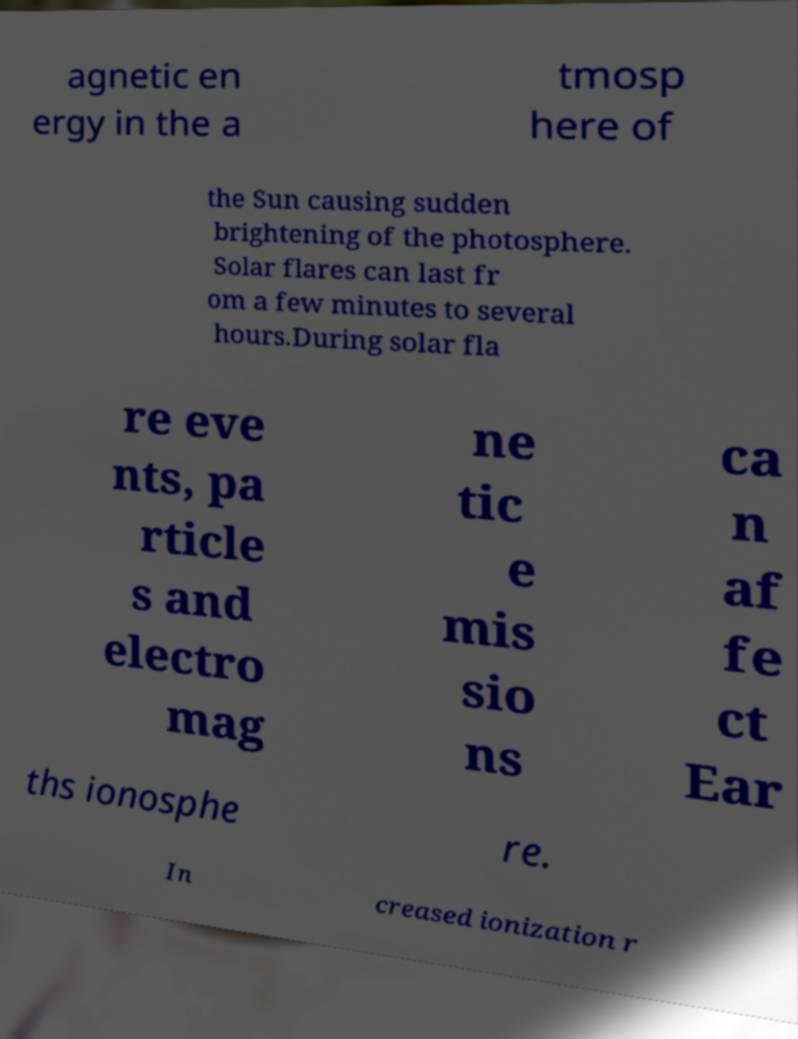Could you assist in decoding the text presented in this image and type it out clearly? agnetic en ergy in the a tmosp here of the Sun causing sudden brightening of the photosphere. Solar flares can last fr om a few minutes to several hours.During solar fla re eve nts, pa rticle s and electro mag ne tic e mis sio ns ca n af fe ct Ear ths ionosphe re. In creased ionization r 